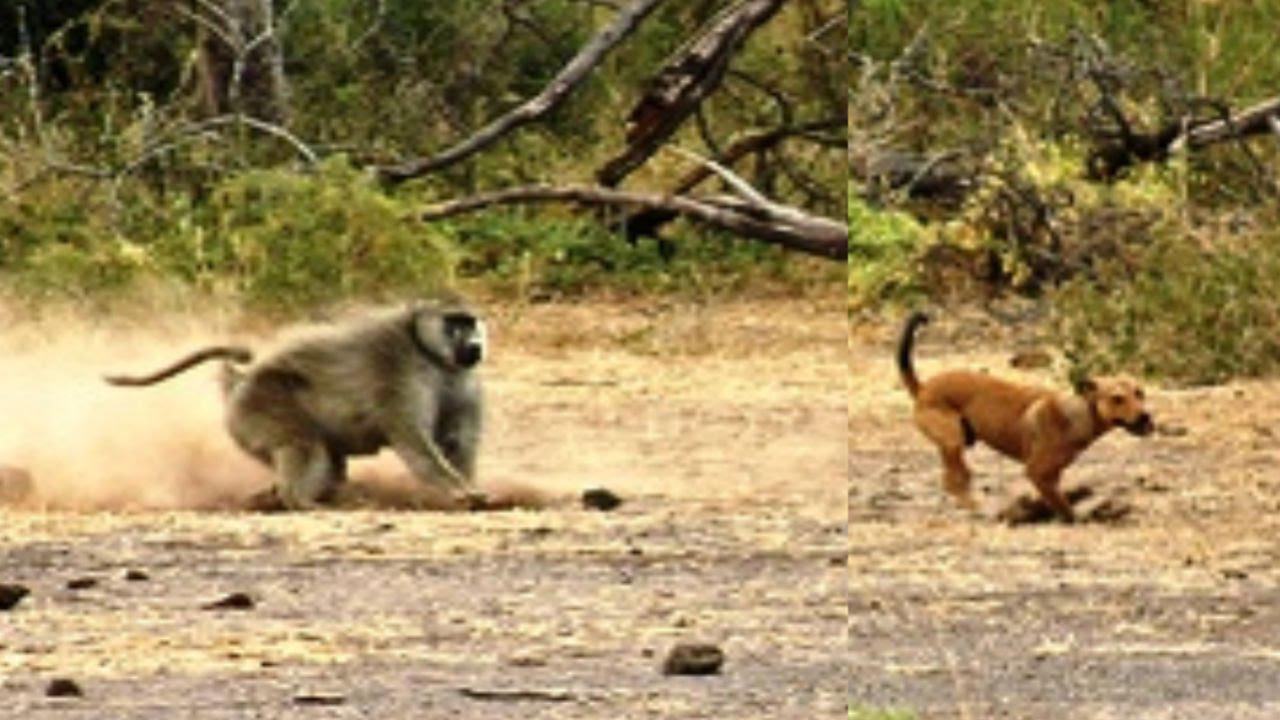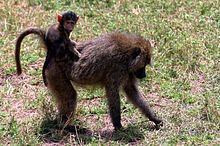The first image is the image on the left, the second image is the image on the right. For the images displayed, is the sentence "There are no more than 4 animals." factually correct? Answer yes or no. Yes. The first image is the image on the left, the second image is the image on the right. For the images displayed, is the sentence "There are exactly two animals in the image on the right." factually correct? Answer yes or no. Yes. 